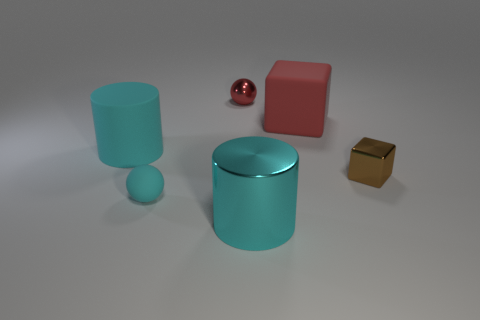There is a large thing in front of the thing to the right of the matte cube; what is its shape?
Provide a succinct answer. Cylinder. There is a rubber thing that is right of the big cyan cylinder right of the cyan cylinder behind the brown block; how big is it?
Make the answer very short. Large. What color is the small object that is the same shape as the big red object?
Offer a terse response. Brown. Do the matte cylinder and the brown thing have the same size?
Offer a terse response. No. What is the material of the big object that is behind the matte cylinder?
Give a very brief answer. Rubber. How many other objects are the same shape as the red matte thing?
Your answer should be compact. 1. Is the shape of the tiny red metallic object the same as the brown shiny thing?
Your answer should be compact. No. There is a large metallic thing; are there any small brown blocks to the left of it?
Make the answer very short. No. How many objects are large cyan metallic objects or large red things?
Ensure brevity in your answer.  2. How many other objects are the same size as the metallic cylinder?
Your answer should be compact. 2. 